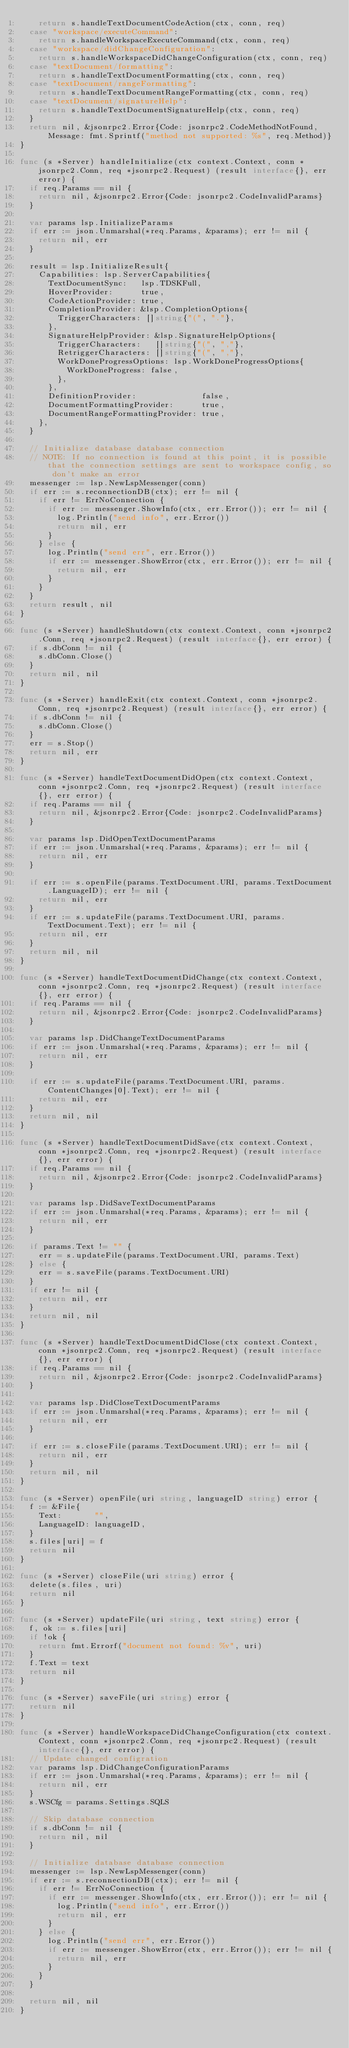Convert code to text. <code><loc_0><loc_0><loc_500><loc_500><_Go_>		return s.handleTextDocumentCodeAction(ctx, conn, req)
	case "workspace/executeCommand":
		return s.handleWorkspaceExecuteCommand(ctx, conn, req)
	case "workspace/didChangeConfiguration":
		return s.handleWorkspaceDidChangeConfiguration(ctx, conn, req)
	case "textDocument/formatting":
		return s.handleTextDocumentFormatting(ctx, conn, req)
	case "textDocument/rangeFormatting":
		return s.handleTextDocumentRangeFormatting(ctx, conn, req)
	case "textDocument/signatureHelp":
		return s.handleTextDocumentSignatureHelp(ctx, conn, req)
	}
	return nil, &jsonrpc2.Error{Code: jsonrpc2.CodeMethodNotFound, Message: fmt.Sprintf("method not supported: %s", req.Method)}
}

func (s *Server) handleInitialize(ctx context.Context, conn *jsonrpc2.Conn, req *jsonrpc2.Request) (result interface{}, err error) {
	if req.Params == nil {
		return nil, &jsonrpc2.Error{Code: jsonrpc2.CodeInvalidParams}
	}

	var params lsp.InitializeParams
	if err := json.Unmarshal(*req.Params, &params); err != nil {
		return nil, err
	}

	result = lsp.InitializeResult{
		Capabilities: lsp.ServerCapabilities{
			TextDocumentSync:   lsp.TDSKFull,
			HoverProvider:      true,
			CodeActionProvider: true,
			CompletionProvider: &lsp.CompletionOptions{
				TriggerCharacters: []string{"(", "."},
			},
			SignatureHelpProvider: &lsp.SignatureHelpOptions{
				TriggerCharacters:   []string{"(", ","},
				RetriggerCharacters: []string{"(", ","},
				WorkDoneProgressOptions: lsp.WorkDoneProgressOptions{
					WorkDoneProgress: false,
				},
			},
			DefinitionProvider:              false,
			DocumentFormattingProvider:      true,
			DocumentRangeFormattingProvider: true,
		},
	}

	// Initialize database database connection
	// NOTE: If no connection is found at this point, it is possible that the connection settings are sent to workspace config, so don't make an error
	messenger := lsp.NewLspMessenger(conn)
	if err := s.reconnectionDB(ctx); err != nil {
		if err != ErrNoConnection {
			if err := messenger.ShowInfo(ctx, err.Error()); err != nil {
				log.Println("send info", err.Error())
				return nil, err
			}
		} else {
			log.Println("send err", err.Error())
			if err := messenger.ShowError(ctx, err.Error()); err != nil {
				return nil, err
			}
		}
	}
	return result, nil
}

func (s *Server) handleShutdown(ctx context.Context, conn *jsonrpc2.Conn, req *jsonrpc2.Request) (result interface{}, err error) {
	if s.dbConn != nil {
		s.dbConn.Close()
	}
	return nil, nil
}

func (s *Server) handleExit(ctx context.Context, conn *jsonrpc2.Conn, req *jsonrpc2.Request) (result interface{}, err error) {
	if s.dbConn != nil {
		s.dbConn.Close()
	}
	err = s.Stop()
	return nil, err
}

func (s *Server) handleTextDocumentDidOpen(ctx context.Context, conn *jsonrpc2.Conn, req *jsonrpc2.Request) (result interface{}, err error) {
	if req.Params == nil {
		return nil, &jsonrpc2.Error{Code: jsonrpc2.CodeInvalidParams}
	}

	var params lsp.DidOpenTextDocumentParams
	if err := json.Unmarshal(*req.Params, &params); err != nil {
		return nil, err
	}

	if err := s.openFile(params.TextDocument.URI, params.TextDocument.LanguageID); err != nil {
		return nil, err
	}
	if err := s.updateFile(params.TextDocument.URI, params.TextDocument.Text); err != nil {
		return nil, err
	}
	return nil, nil
}

func (s *Server) handleTextDocumentDidChange(ctx context.Context, conn *jsonrpc2.Conn, req *jsonrpc2.Request) (result interface{}, err error) {
	if req.Params == nil {
		return nil, &jsonrpc2.Error{Code: jsonrpc2.CodeInvalidParams}
	}

	var params lsp.DidChangeTextDocumentParams
	if err := json.Unmarshal(*req.Params, &params); err != nil {
		return nil, err
	}

	if err := s.updateFile(params.TextDocument.URI, params.ContentChanges[0].Text); err != nil {
		return nil, err
	}
	return nil, nil
}

func (s *Server) handleTextDocumentDidSave(ctx context.Context, conn *jsonrpc2.Conn, req *jsonrpc2.Request) (result interface{}, err error) {
	if req.Params == nil {
		return nil, &jsonrpc2.Error{Code: jsonrpc2.CodeInvalidParams}
	}

	var params lsp.DidSaveTextDocumentParams
	if err := json.Unmarshal(*req.Params, &params); err != nil {
		return nil, err
	}

	if params.Text != "" {
		err = s.updateFile(params.TextDocument.URI, params.Text)
	} else {
		err = s.saveFile(params.TextDocument.URI)
	}
	if err != nil {
		return nil, err
	}
	return nil, nil
}

func (s *Server) handleTextDocumentDidClose(ctx context.Context, conn *jsonrpc2.Conn, req *jsonrpc2.Request) (result interface{}, err error) {
	if req.Params == nil {
		return nil, &jsonrpc2.Error{Code: jsonrpc2.CodeInvalidParams}
	}

	var params lsp.DidCloseTextDocumentParams
	if err := json.Unmarshal(*req.Params, &params); err != nil {
		return nil, err
	}

	if err := s.closeFile(params.TextDocument.URI); err != nil {
		return nil, err
	}
	return nil, nil
}

func (s *Server) openFile(uri string, languageID string) error {
	f := &File{
		Text:       "",
		LanguageID: languageID,
	}
	s.files[uri] = f
	return nil
}

func (s *Server) closeFile(uri string) error {
	delete(s.files, uri)
	return nil
}

func (s *Server) updateFile(uri string, text string) error {
	f, ok := s.files[uri]
	if !ok {
		return fmt.Errorf("document not found: %v", uri)
	}
	f.Text = text
	return nil
}

func (s *Server) saveFile(uri string) error {
	return nil
}

func (s *Server) handleWorkspaceDidChangeConfiguration(ctx context.Context, conn *jsonrpc2.Conn, req *jsonrpc2.Request) (result interface{}, err error) {
	// Update changed configration
	var params lsp.DidChangeConfigurationParams
	if err := json.Unmarshal(*req.Params, &params); err != nil {
		return nil, err
	}
	s.WSCfg = params.Settings.SQLS

	// Skip database connection
	if s.dbConn != nil {
		return nil, nil
	}

	// Initialize database database connection
	messenger := lsp.NewLspMessenger(conn)
	if err := s.reconnectionDB(ctx); err != nil {
		if err != ErrNoConnection {
			if err := messenger.ShowInfo(ctx, err.Error()); err != nil {
				log.Println("send info", err.Error())
				return nil, err
			}
		} else {
			log.Println("send err", err.Error())
			if err := messenger.ShowError(ctx, err.Error()); err != nil {
				return nil, err
			}
		}
	}

	return nil, nil
}
</code> 